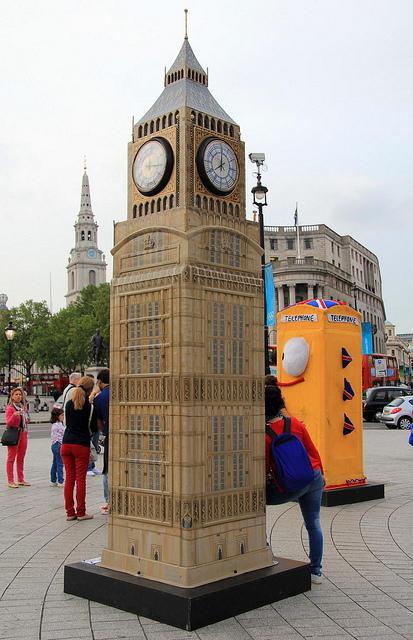Is the clock tower tall?
Write a very short answer. No. Is this a functioning clock tower?
Keep it brief. No. What color is the backpack?
Quick response, please. Blue. 